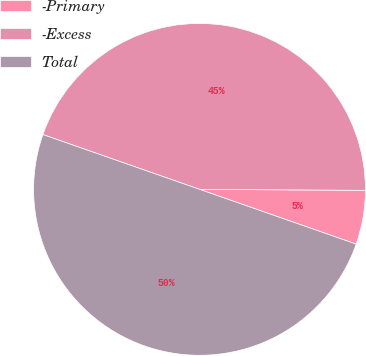<chart> <loc_0><loc_0><loc_500><loc_500><pie_chart><fcel>-Primary<fcel>-Excess<fcel>Total<nl><fcel>5.26%<fcel>44.74%<fcel>50.0%<nl></chart> 